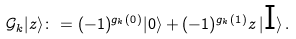Convert formula to latex. <formula><loc_0><loc_0><loc_500><loc_500>\mathcal { G } _ { k } | z \rangle \colon = ( - 1 ) ^ { g _ { k } ( 0 ) } | 0 \rangle + ( - 1 ) ^ { g _ { k } ( 1 ) } z \, | \text {I} \rangle \, .</formula> 